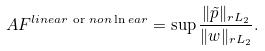<formula> <loc_0><loc_0><loc_500><loc_500>A F ^ { l i n e a r \text { or } n o n \ln e a r } = \sup \frac { \| \tilde { p } \| _ { r { L } _ { 2 } } } { \| w \| _ { r { L } _ { 2 } } } .</formula> 